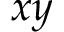Convert formula to latex. <formula><loc_0><loc_0><loc_500><loc_500>x y</formula> 